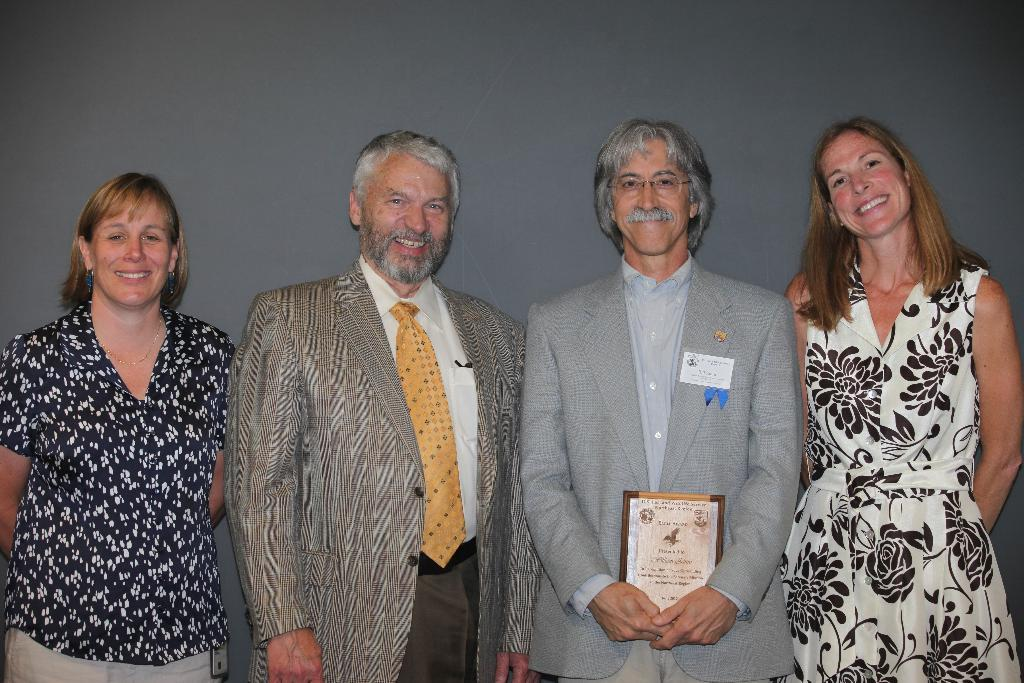How many women are present in the image? There are four women in the image. What are the women wearing in the image? The women are wearing coats and shirts. What is the facial expression of the women in the image? All the women are smiling in the image. Can you describe the positioning of the women in the image? Two women are standing in the middle, and two women are on either side of the image. What type of clam is being served on a plate in the image? There is no clam or plate present in the image; it features four women wearing coats and shirts. Can you tell me how much the receipt costs in the image? There is no receipt present in the image. 